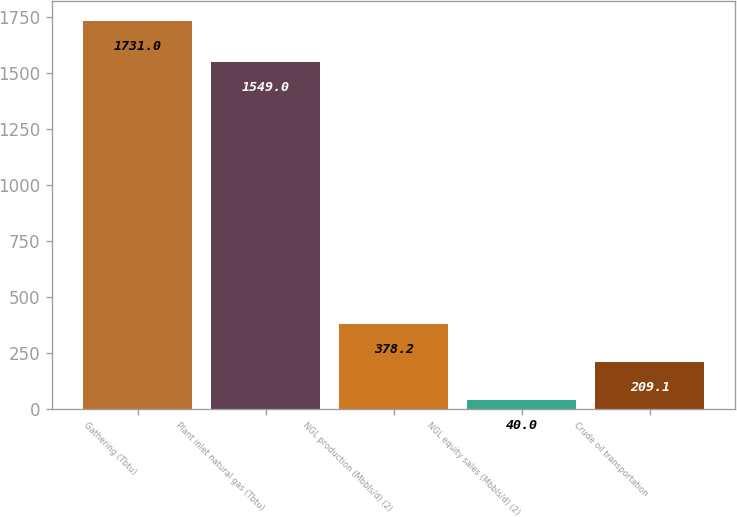Convert chart. <chart><loc_0><loc_0><loc_500><loc_500><bar_chart><fcel>Gathering (Tbtu)<fcel>Plant inlet natural gas (Tbtu)<fcel>NGL production (Mbbls/d) (2)<fcel>NGL equity sales (Mbbls/d) (2)<fcel>Crude oil transportation<nl><fcel>1731<fcel>1549<fcel>378.2<fcel>40<fcel>209.1<nl></chart> 